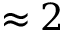Convert formula to latex. <formula><loc_0><loc_0><loc_500><loc_500>\approx 2</formula> 